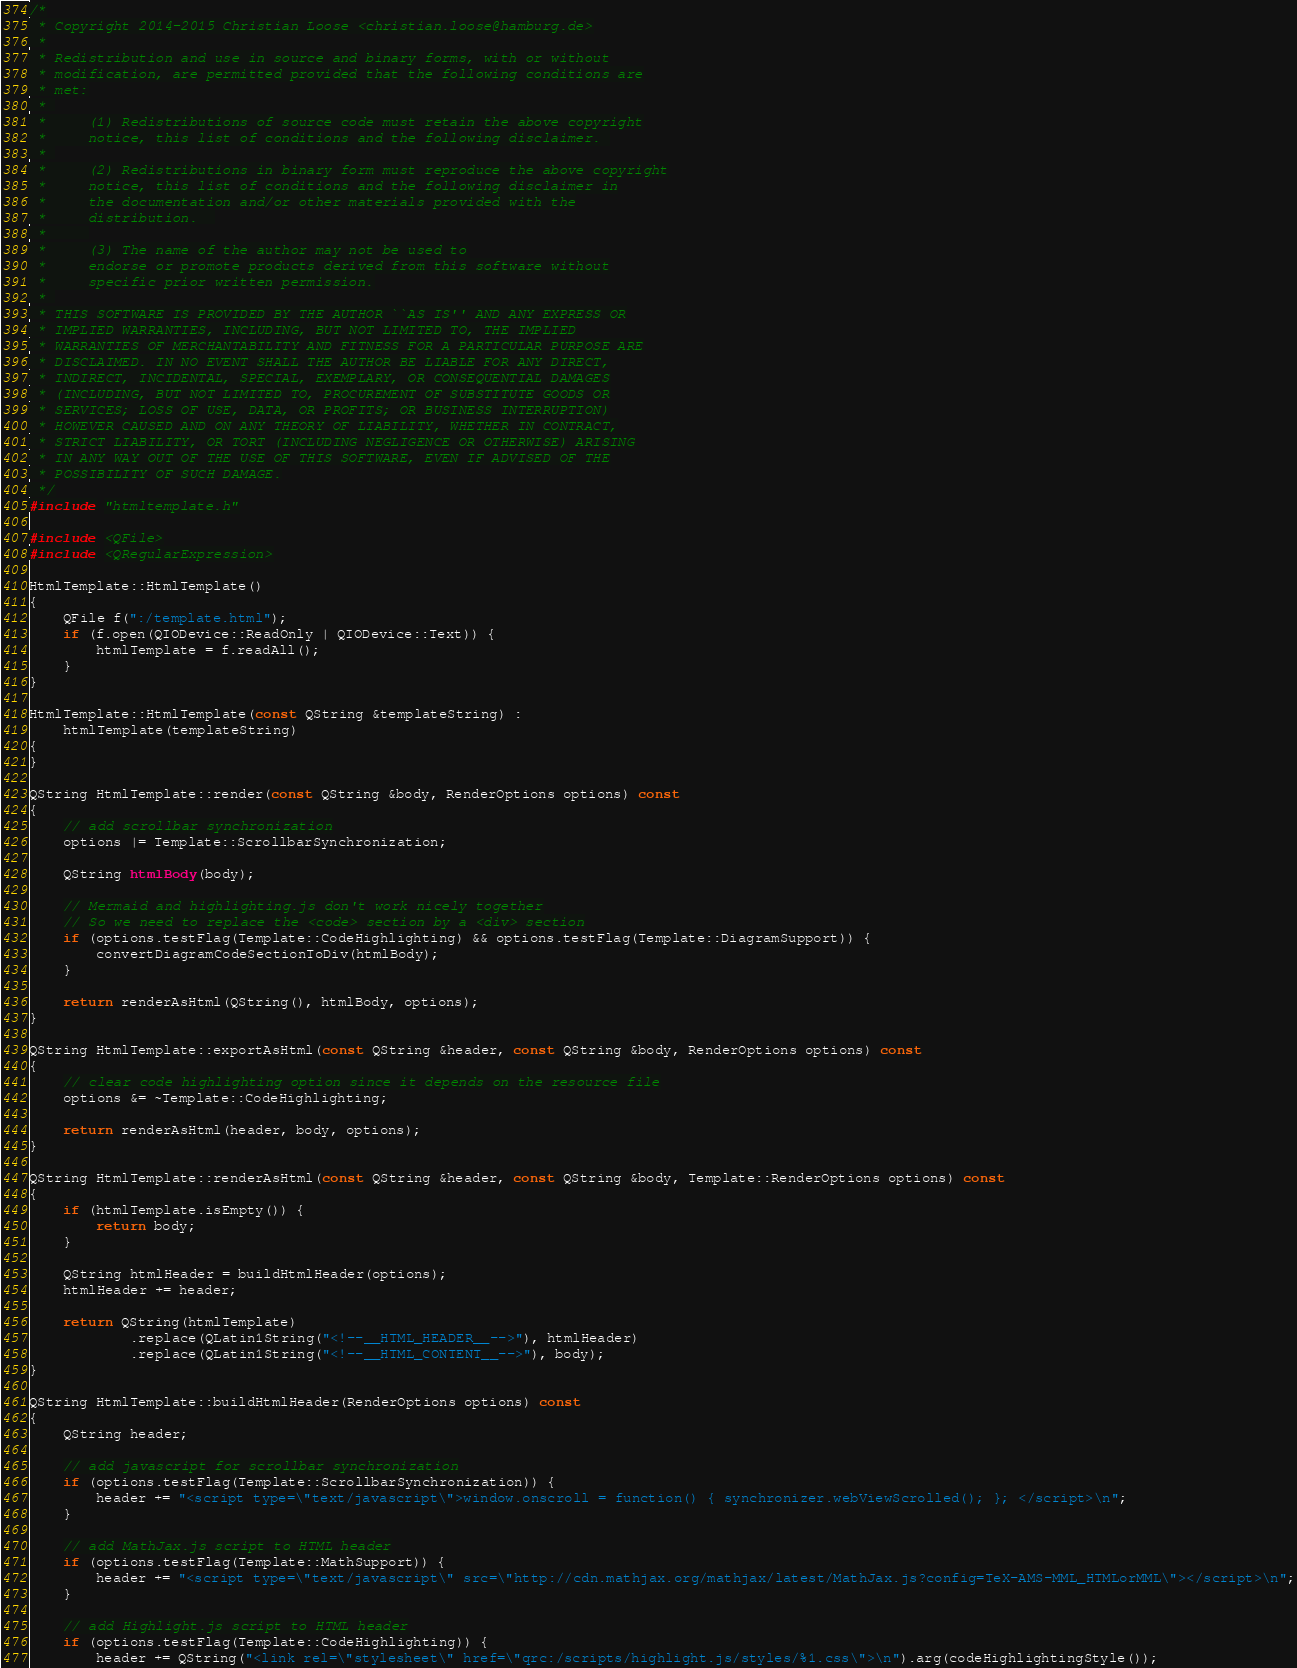<code> <loc_0><loc_0><loc_500><loc_500><_C++_>/*
 * Copyright 2014-2015 Christian Loose <christian.loose@hamburg.de>
 *
 * Redistribution and use in source and binary forms, with or without
 * modification, are permitted provided that the following conditions are
 * met:
 * 
 *     (1) Redistributions of source code must retain the above copyright
 *     notice, this list of conditions and the following disclaimer. 
 * 
 *     (2) Redistributions in binary form must reproduce the above copyright
 *     notice, this list of conditions and the following disclaimer in
 *     the documentation and/or other materials provided with the
 *     distribution.  
 *     
 *     (3) The name of the author may not be used to
 *     endorse or promote products derived from this software without
 *     specific prior written permission.
 * 
 * THIS SOFTWARE IS PROVIDED BY THE AUTHOR ``AS IS'' AND ANY EXPRESS OR
 * IMPLIED WARRANTIES, INCLUDING, BUT NOT LIMITED TO, THE IMPLIED
 * WARRANTIES OF MERCHANTABILITY AND FITNESS FOR A PARTICULAR PURPOSE ARE
 * DISCLAIMED. IN NO EVENT SHALL THE AUTHOR BE LIABLE FOR ANY DIRECT,
 * INDIRECT, INCIDENTAL, SPECIAL, EXEMPLARY, OR CONSEQUENTIAL DAMAGES
 * (INCLUDING, BUT NOT LIMITED TO, PROCUREMENT OF SUBSTITUTE GOODS OR
 * SERVICES; LOSS OF USE, DATA, OR PROFITS; OR BUSINESS INTERRUPTION)
 * HOWEVER CAUSED AND ON ANY THEORY OF LIABILITY, WHETHER IN CONTRACT,
 * STRICT LIABILITY, OR TORT (INCLUDING NEGLIGENCE OR OTHERWISE) ARISING
 * IN ANY WAY OUT OF THE USE OF THIS SOFTWARE, EVEN IF ADVISED OF THE
 * POSSIBILITY OF SUCH DAMAGE.
 */
#include "htmltemplate.h"

#include <QFile>
#include <QRegularExpression>

HtmlTemplate::HtmlTemplate()
{
    QFile f(":/template.html");
    if (f.open(QIODevice::ReadOnly | QIODevice::Text)) {
        htmlTemplate = f.readAll();
    }
}

HtmlTemplate::HtmlTemplate(const QString &templateString) :
	htmlTemplate(templateString)
{
}

QString HtmlTemplate::render(const QString &body, RenderOptions options) const
{
    // add scrollbar synchronization
    options |= Template::ScrollbarSynchronization;

    QString htmlBody(body);

    // Mermaid and highlighting.js don't work nicely together
    // So we need to replace the <code> section by a <div> section
    if (options.testFlag(Template::CodeHighlighting) && options.testFlag(Template::DiagramSupport)) {
        convertDiagramCodeSectionToDiv(htmlBody);
    }

    return renderAsHtml(QString(), htmlBody, options);
}

QString HtmlTemplate::exportAsHtml(const QString &header, const QString &body, RenderOptions options) const
{
    // clear code highlighting option since it depends on the resource file
    options &= ~Template::CodeHighlighting;

    return renderAsHtml(header, body, options);
}

QString HtmlTemplate::renderAsHtml(const QString &header, const QString &body, Template::RenderOptions options) const
{
    if (htmlTemplate.isEmpty()) {
        return body;
    }

    QString htmlHeader = buildHtmlHeader(options);
    htmlHeader += header;

    return QString(htmlTemplate)
            .replace(QLatin1String("<!--__HTML_HEADER__-->"), htmlHeader)
            .replace(QLatin1String("<!--__HTML_CONTENT__-->"), body);
}

QString HtmlTemplate::buildHtmlHeader(RenderOptions options) const
{
    QString header;

    // add javascript for scrollbar synchronization
    if (options.testFlag(Template::ScrollbarSynchronization)) {
        header += "<script type=\"text/javascript\">window.onscroll = function() { synchronizer.webViewScrolled(); }; </script>\n";
    }

    // add MathJax.js script to HTML header
    if (options.testFlag(Template::MathSupport)) {
        header += "<script type=\"text/javascript\" src=\"http://cdn.mathjax.org/mathjax/latest/MathJax.js?config=TeX-AMS-MML_HTMLorMML\"></script>\n";
    }

    // add Highlight.js script to HTML header
    if (options.testFlag(Template::CodeHighlighting)) {
        header += QString("<link rel=\"stylesheet\" href=\"qrc:/scripts/highlight.js/styles/%1.css\">\n").arg(codeHighlightingStyle());</code> 